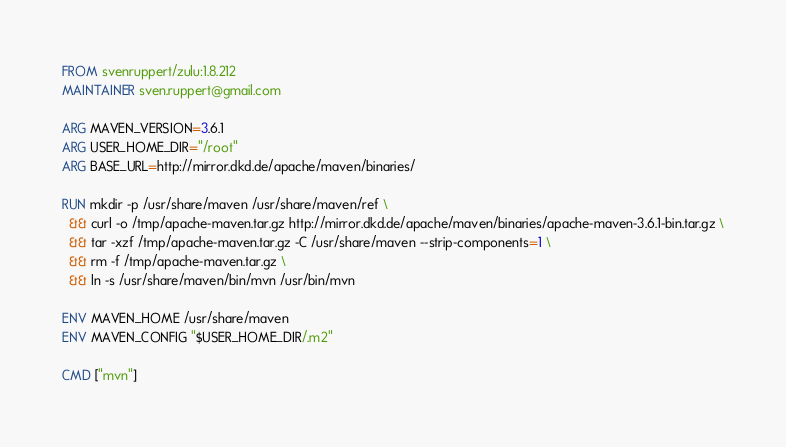Convert code to text. <code><loc_0><loc_0><loc_500><loc_500><_Dockerfile_>FROM svenruppert/zulu:1.8.212
MAINTAINER sven.ruppert@gmail.com

ARG MAVEN_VERSION=3.6.1
ARG USER_HOME_DIR="/root"
ARG BASE_URL=http://mirror.dkd.de/apache/maven/binaries/

RUN mkdir -p /usr/share/maven /usr/share/maven/ref \
  && curl -o /tmp/apache-maven.tar.gz http://mirror.dkd.de/apache/maven/binaries/apache-maven-3.6.1-bin.tar.gz \
  && tar -xzf /tmp/apache-maven.tar.gz -C /usr/share/maven --strip-components=1 \
  && rm -f /tmp/apache-maven.tar.gz \
  && ln -s /usr/share/maven/bin/mvn /usr/bin/mvn

ENV MAVEN_HOME /usr/share/maven
ENV MAVEN_CONFIG "$USER_HOME_DIR/.m2"

CMD ["mvn"]</code> 